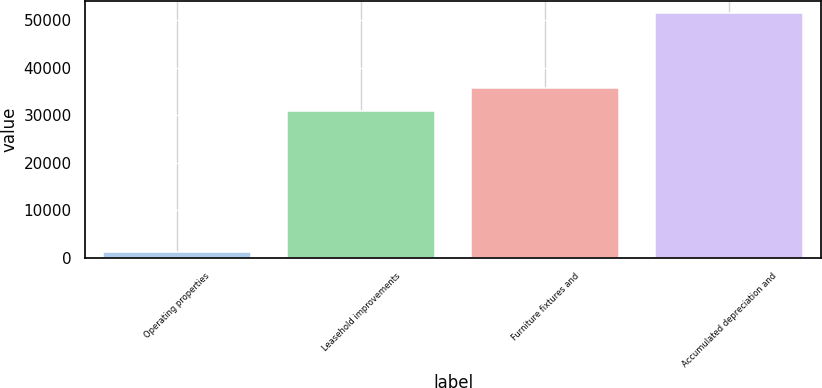Convert chart. <chart><loc_0><loc_0><loc_500><loc_500><bar_chart><fcel>Operating properties<fcel>Leasehold improvements<fcel>Furniture fixtures and<fcel>Accumulated depreciation and<nl><fcel>1300<fcel>30825<fcel>35842.3<fcel>51473<nl></chart> 